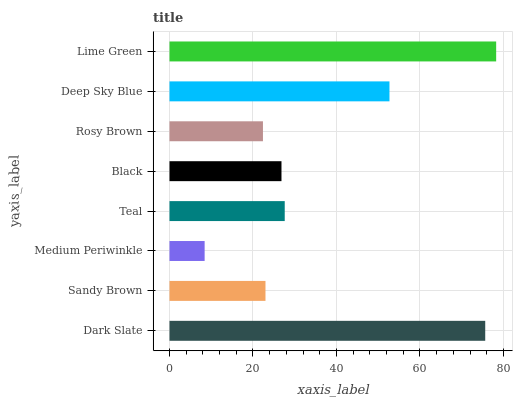Is Medium Periwinkle the minimum?
Answer yes or no. Yes. Is Lime Green the maximum?
Answer yes or no. Yes. Is Sandy Brown the minimum?
Answer yes or no. No. Is Sandy Brown the maximum?
Answer yes or no. No. Is Dark Slate greater than Sandy Brown?
Answer yes or no. Yes. Is Sandy Brown less than Dark Slate?
Answer yes or no. Yes. Is Sandy Brown greater than Dark Slate?
Answer yes or no. No. Is Dark Slate less than Sandy Brown?
Answer yes or no. No. Is Teal the high median?
Answer yes or no. Yes. Is Black the low median?
Answer yes or no. Yes. Is Rosy Brown the high median?
Answer yes or no. No. Is Dark Slate the low median?
Answer yes or no. No. 